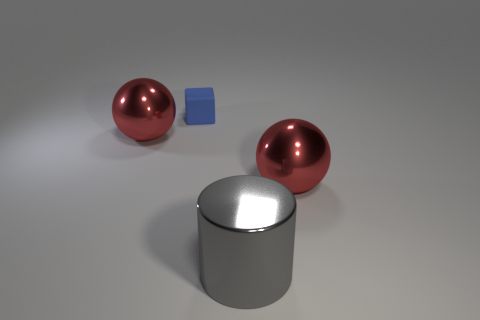Add 3 big red metal balls. How many objects exist? 7 Subtract all cylinders. How many objects are left? 3 Subtract all red blocks. Subtract all cubes. How many objects are left? 3 Add 2 metallic cylinders. How many metallic cylinders are left? 3 Add 4 big things. How many big things exist? 7 Subtract 0 blue balls. How many objects are left? 4 